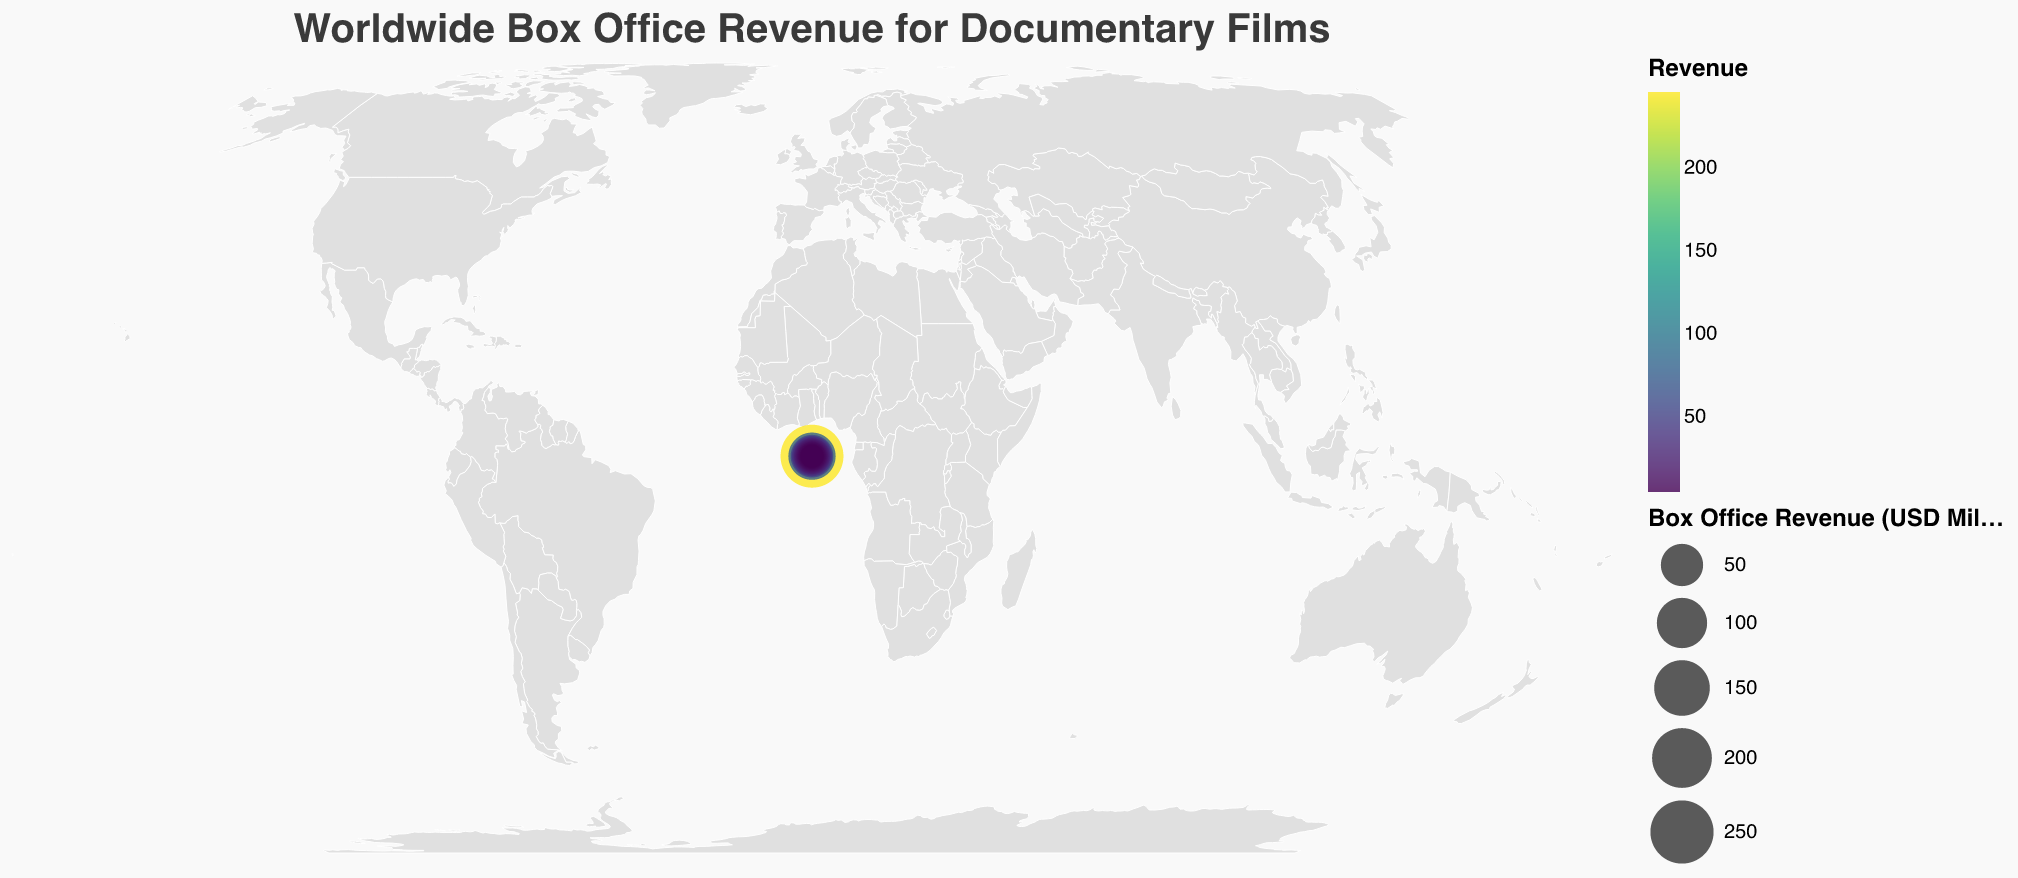What is the title of the plot? The title is usually positioned prominently at the top of the figure and often summarizes the main subject of the visualization. In this case, it states the main topic of the plot.
Answer: Worldwide Box Office Revenue for Documentary Films Which country has the highest box office revenue for documentary films? The size and color intensity of the circles indicate the revenue. The largest and most intense circle can be found in the United States, making it the country with the highest revenue.
Answer: United States How much is the box office revenue for documentary films in Germany? By locating Germany on the map and referring to the tooltip or hovering over the corresponding circle, we find that the box office revenue is $41.8 million.
Answer: 41.8 million USD Compare the box office revenues of France and Canada. Which one is higher? By inspecting the circles representing France and Canada, we see that the circle for France is larger and more intense in color compared to Canada's, indicating higher revenue. France has $52.1 million, whereas Canada has $29.7 million.
Answer: France What is the total box office revenue for documentary films in the top 3 countries? The top 3 countries by box office revenue are the United States ($245.6 million), the United Kingdom ($78.3 million), and France ($52.1 million). Summing these up: 245.6 + 78.3 + 52.1 = 376 million USD.
Answer: 376 million USD Which countries have box office revenues between 20 and 30 million USD? By examining the visual data, we find that the countries with revenues in that range are Canada ($29.7 million), Australia ($25.4 million), and China ($22.9 million).
Answer: Canada, Australia, China What is the box office revenue difference between Italy and Spain? Italy has a revenue of $19.6 million, and Spain has a revenue of $17.2 million. The difference is calculated as 19.6 - 17.2 = 2.4 million USD.
Answer: 2.4 million USD How does the box office revenue of Brazil compare to that of South Korea? By checking the circles for Brazil and South Korea, we see that Brazil has a revenue of $9.5 million, which is higher than South Korea's $8.7 million.
Answer: Brazil What is the median box office revenue value among all the countries listed? To find the median, list all revenue values in ascending order and find the middle value. The sorted revenues are: 4.6, 5.2, 5.9, 6.8, 7.6, 8.7, 9.5, 10.9, 12.3, 14.8, 17.2, 19.6, 22.9, 25.4, 29.7, 36.5, 41.8, 52.1, 78.3, 245.6. With 20 values, the median is the average of the 10th and 11th values: (14.8 + 17.2) / 2 = 16 million USD.
Answer: 16 million USD What is the smallest box office revenue value shown on the plot? The smallest revenue value can be found by identifying the smallest circle on the map or the smallest number in the data list, which belongs to Norway with $4.6 million.
Answer: 4.6 million USD 